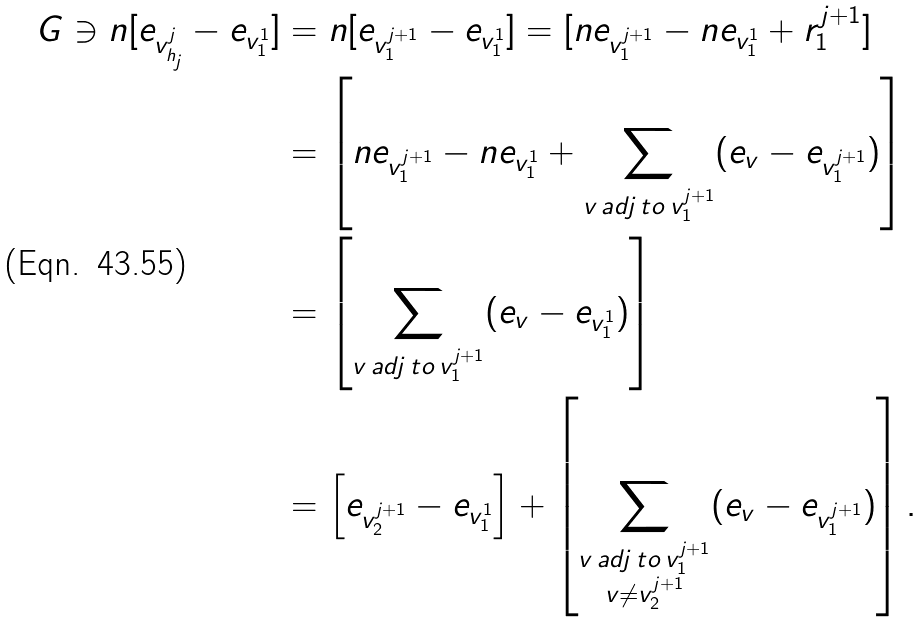Convert formula to latex. <formula><loc_0><loc_0><loc_500><loc_500>G \ni n [ e _ { v _ { h _ { j } } ^ { j } } - e _ { v _ { 1 } ^ { 1 } } ] & = n [ e _ { v _ { 1 } ^ { j + 1 } } - e _ { v _ { 1 } ^ { 1 } } ] = [ n e _ { v _ { 1 } ^ { j + 1 } } - n e _ { v _ { 1 } ^ { 1 } } + r _ { 1 } ^ { j + 1 } ] \\ & = \left [ n e _ { v _ { 1 } ^ { j + 1 } } - n e _ { v _ { 1 } ^ { 1 } } + \sum _ { v \, a d j \, t o \, v _ { 1 } ^ { j + 1 } } ( e _ { v } - e _ { v _ { 1 } ^ { j + 1 } } ) \right ] \\ & = \left [ \sum _ { v \, a d j \, t o \, v _ { 1 } ^ { j + 1 } } ( e _ { v } - e _ { v _ { 1 } ^ { 1 } } ) \right ] \\ & = \left [ e _ { v _ { 2 } ^ { j + 1 } } - e _ { v _ { 1 } ^ { 1 } } \right ] + \left [ \sum _ { \substack { v \, a d j \, t o \, v _ { 1 } ^ { j + 1 } \\ v \neq v _ { 2 } ^ { j + 1 } } } ( e _ { v } - e _ { v _ { 1 } ^ { j + 1 } } ) \right ] .</formula> 